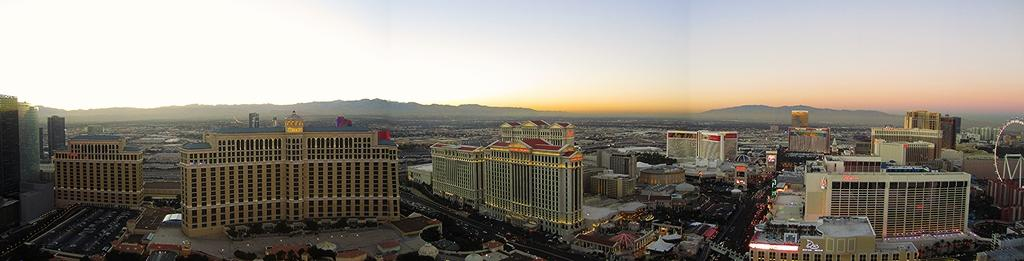What type of structures can be seen in the image? There are buildings in the image. What else is visible in the image besides the buildings? There are streets in the image. What is happening on the streets? Vehicles are moving in the streets. What is the condition of the sky in the image? The sky is clear in the image. How many cushions are placed on the fifth building in the image? There is no mention of cushions or a fifth building in the image. 